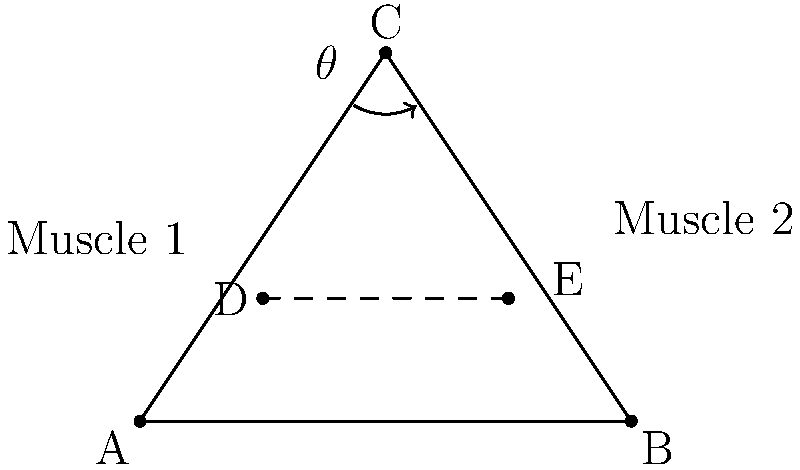In the simplified skeletal diagram above, two muscles (Muscle 1 and Muscle 2) are attached to a bone represented by triangle ABC. The joint is located at point C, and the dashed line DE represents the line of action for both muscles. If the angle $\theta$ between the bone and the horizontal is 30°, and CB = 5 cm, calculate the difference in moment arms between Muscle 1 and Muscle 2 about the joint at C. To solve this problem, we'll follow these steps:

1) First, we need to understand that the moment arm is the perpendicular distance from the joint to the line of action of the muscle.

2) In this case, the moment arms for both muscles are the perpendicular distances from point C to line DE.

3) We can calculate these distances using trigonometry. The moment arm for each muscle will be:
   Moment arm = CB * sin(angle between CB and DE)

4) For Muscle 1:
   Angle between CB and DE = 90° - θ = 90° - 30° = 60°
   Moment arm 1 = 5 cm * sin(60°) = 5 * 0.866 = 4.33 cm

5) For Muscle 2:
   Angle between CB and DE = θ = 30°
   Moment arm 2 = 5 cm * sin(30°) = 5 * 0.5 = 2.5 cm

6) The difference in moment arms:
   Difference = Moment arm 1 - Moment arm 2
              = 4.33 cm - 2.5 cm
              = 1.83 cm

Therefore, the difference in moment arms between Muscle 1 and Muscle 2 is 1.83 cm.
Answer: 1.83 cm 